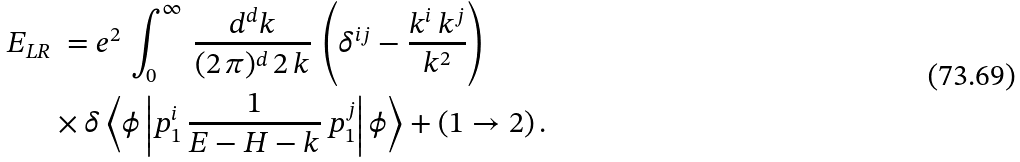Convert formula to latex. <formula><loc_0><loc_0><loc_500><loc_500>E _ { L R } & \ = e ^ { 2 } \, \int _ { 0 } ^ { \infty } \, \frac { d ^ { d } k } { ( 2 \, \pi ) ^ { d } \, 2 \, k } \, \left ( \delta ^ { i j } - \frac { k ^ { i } \, k ^ { j } } { k ^ { 2 } } \right ) \\ & \times \delta \left \langle \phi \left | p _ { 1 } ^ { i } \, \frac { 1 } { E - H - k } \, p _ { 1 } ^ { j } \right | \phi \right \rangle + ( 1 \rightarrow 2 ) \, .</formula> 